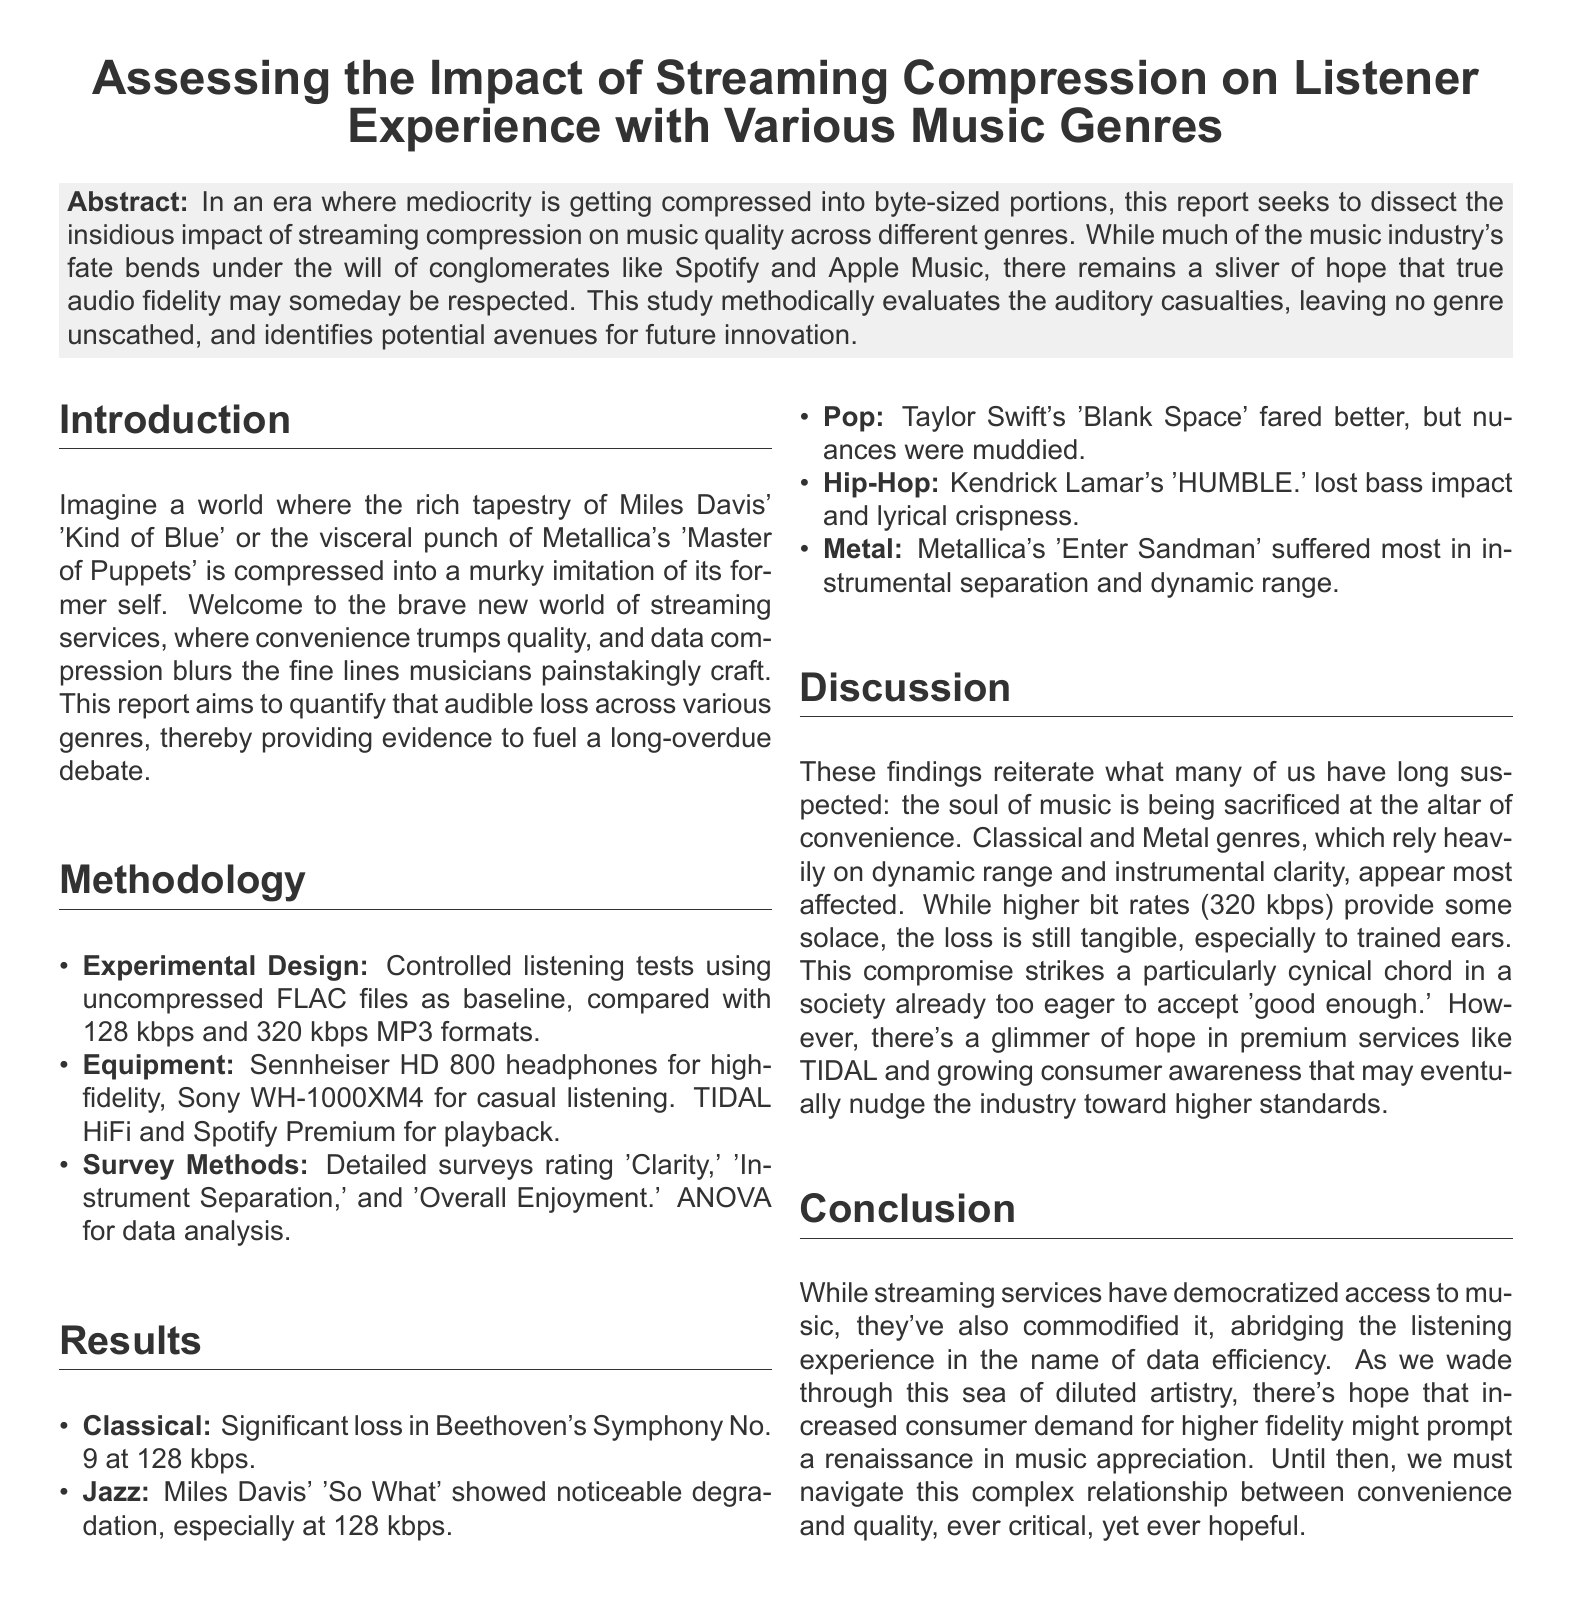what is the main focus of the report? The report dissects the impact of streaming compression on music quality across different genres.
Answer: impact of streaming compression which genres were evaluated in the study? The report mentions Classical, Jazz, Pop, Hip-Hop, and Metal as the genres evaluated.
Answer: Classical, Jazz, Pop, Hip-Hop, Metal what equipment was used for high-fidelity listening? Sennheiser HD 800 headphones were specified for high-fidelity listening.
Answer: Sennheiser HD 800 which song showed significant loss at 128 kbps in the Classical genre? The report states that Beethoven's Symphony No. 9 showed significant loss at 128 kbps.
Answer: Beethoven's Symphony No. 9 how did Taylor Swift's song fare in the study? The research found that Taylor Swift's 'Blank Space' fared better but had muddied nuances.
Answer: fared better, muddied nuances what statistical method was employed for data analysis? The report utilized ANOVA for data analysis.
Answer: ANOVA which service provides higher quality audio according to the report? TIDAL HiFi is mentioned as a service that provides higher quality audio.
Answer: TIDAL HiFi what was the conclusion regarding consumer demand? The conclusion suggests that increased consumer demand for higher fidelity might prompt a renaissance in music appreciation.
Answer: renaissance in music appreciation how does the report evaluate the state of music in the current streaming age? The report posits that streaming services have commodified music and diluted the listening experience in the name of efficiency.
Answer: commodified music and diluted experience 